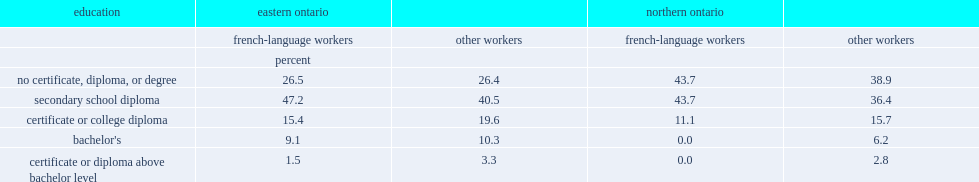Which group of workers in northern ontario was more likely not to have a certificate, diploma or degree or to have a high school diploma? french-language workers or other workers? French-language workers. Which group of workers in northern ontario was less likely to have a college diploma or certificate? french-language workers or other workers? French-language workers. 